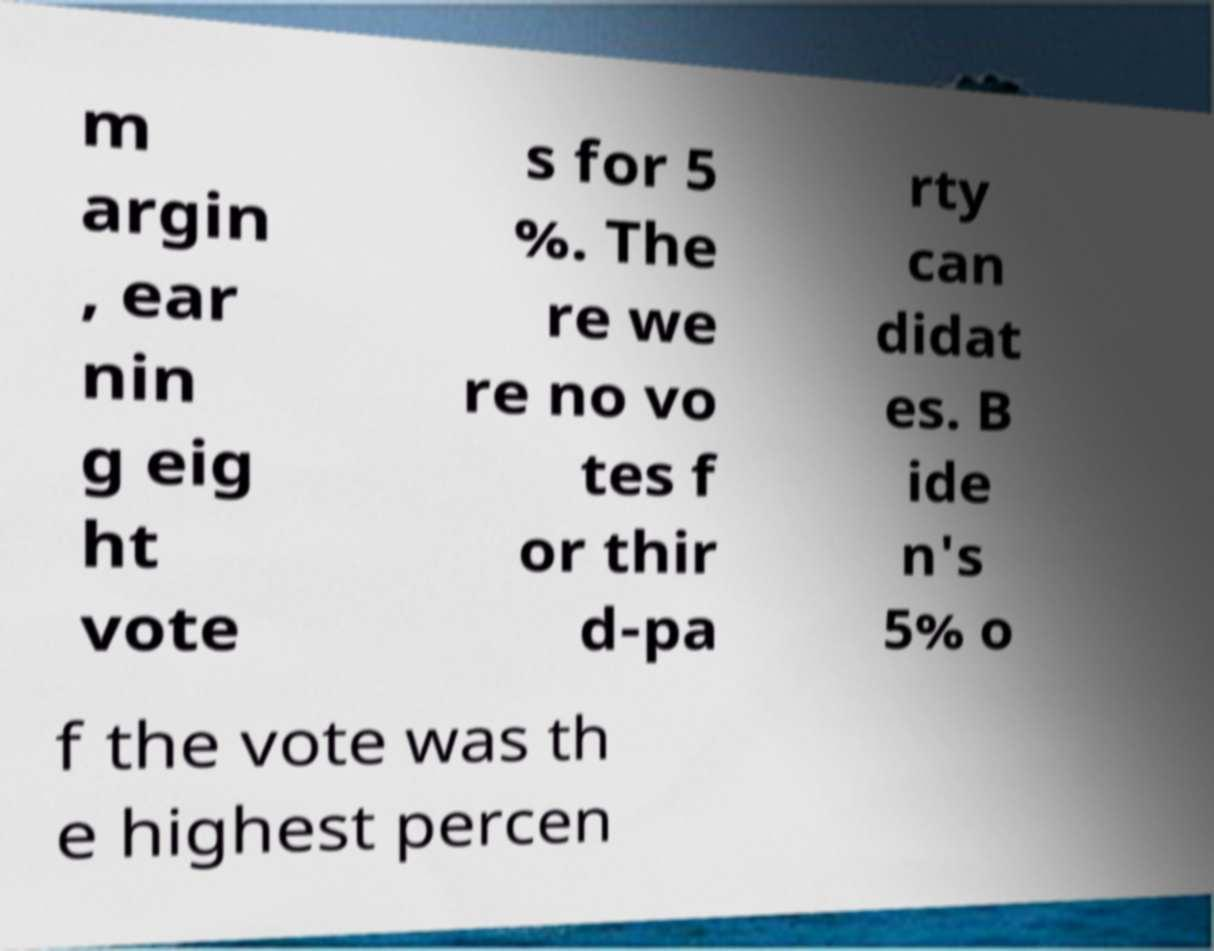For documentation purposes, I need the text within this image transcribed. Could you provide that? m argin , ear nin g eig ht vote s for 5 %. The re we re no vo tes f or thir d-pa rty can didat es. B ide n's 5% o f the vote was th e highest percen 